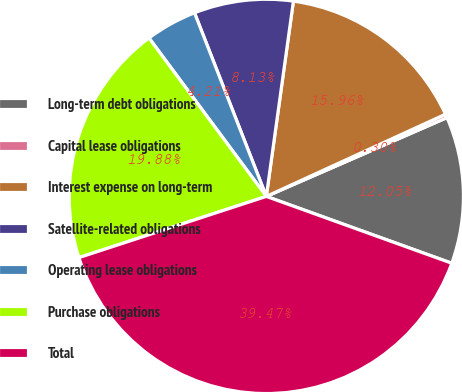<chart> <loc_0><loc_0><loc_500><loc_500><pie_chart><fcel>Long-term debt obligations<fcel>Capital lease obligations<fcel>Interest expense on long-term<fcel>Satellite-related obligations<fcel>Operating lease obligations<fcel>Purchase obligations<fcel>Total<nl><fcel>12.05%<fcel>0.3%<fcel>15.96%<fcel>8.13%<fcel>4.21%<fcel>19.88%<fcel>39.47%<nl></chart> 